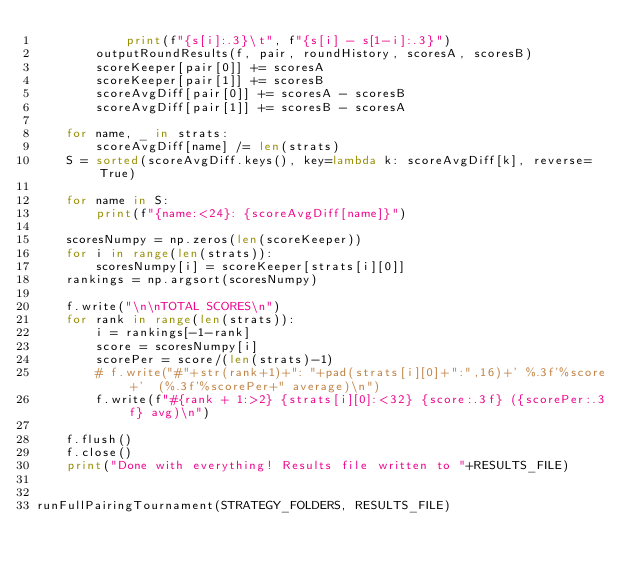Convert code to text. <code><loc_0><loc_0><loc_500><loc_500><_Python_>            print(f"{s[i]:.3}\t", f"{s[i] - s[1-i]:.3}")
        outputRoundResults(f, pair, roundHistory, scoresA, scoresB)
        scoreKeeper[pair[0]] += scoresA
        scoreKeeper[pair[1]] += scoresB
        scoreAvgDiff[pair[0]] += scoresA - scoresB
        scoreAvgDiff[pair[1]] += scoresB - scoresA

    for name, _ in strats:
        scoreAvgDiff[name] /= len(strats)
    S = sorted(scoreAvgDiff.keys(), key=lambda k: scoreAvgDiff[k], reverse=True)

    for name in S:
        print(f"{name:<24}: {scoreAvgDiff[name]}")
        
    scoresNumpy = np.zeros(len(scoreKeeper))
    for i in range(len(strats)):
        scoresNumpy[i] = scoreKeeper[strats[i][0]]
    rankings = np.argsort(scoresNumpy)

    f.write("\n\nTOTAL SCORES\n")
    for rank in range(len(strats)):
        i = rankings[-1-rank]
        score = scoresNumpy[i]
        scorePer = score/(len(strats)-1)
        # f.write("#"+str(rank+1)+": "+pad(strats[i][0]+":",16)+' %.3f'%score+'  (%.3f'%scorePer+" average)\n")
        f.write(f"#{rank + 1:>2} {strats[i][0]:<32} {score:.3f} ({scorePer:.3f} avg)\n")
        
    f.flush()
    f.close()
    print("Done with everything! Results file written to "+RESULTS_FILE)
    
    
runFullPairingTournament(STRATEGY_FOLDERS, RESULTS_FILE)
</code> 